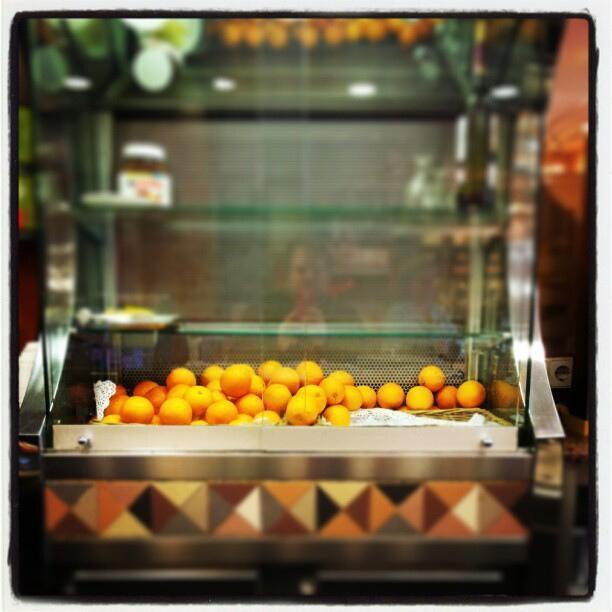What vitamin does this fruit contain the most?
Make your selection from the four choices given to correctly answer the question.
Options: Vitamin, vitamin b, vitamin c, vitamin e. Vitamin c. 